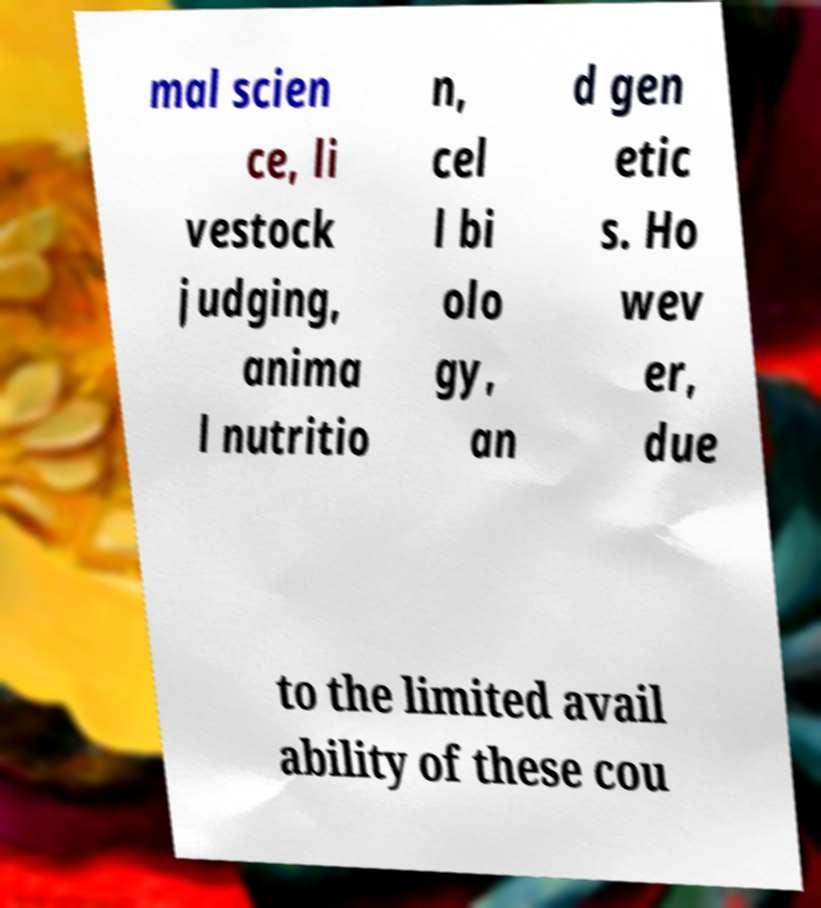For documentation purposes, I need the text within this image transcribed. Could you provide that? mal scien ce, li vestock judging, anima l nutritio n, cel l bi olo gy, an d gen etic s. Ho wev er, due to the limited avail ability of these cou 